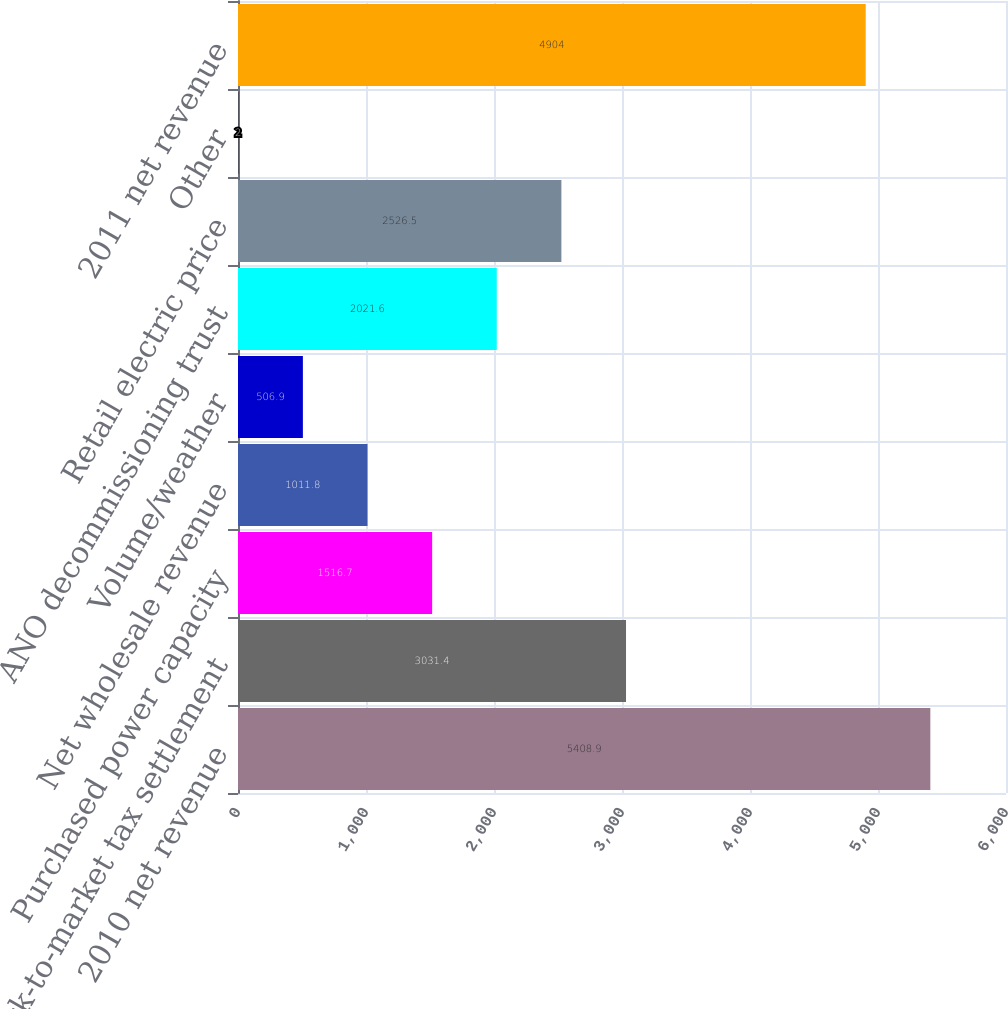<chart> <loc_0><loc_0><loc_500><loc_500><bar_chart><fcel>2010 net revenue<fcel>Mark-to-market tax settlement<fcel>Purchased power capacity<fcel>Net wholesale revenue<fcel>Volume/weather<fcel>ANO decommissioning trust<fcel>Retail electric price<fcel>Other<fcel>2011 net revenue<nl><fcel>5408.9<fcel>3031.4<fcel>1516.7<fcel>1011.8<fcel>506.9<fcel>2021.6<fcel>2526.5<fcel>2<fcel>4904<nl></chart> 